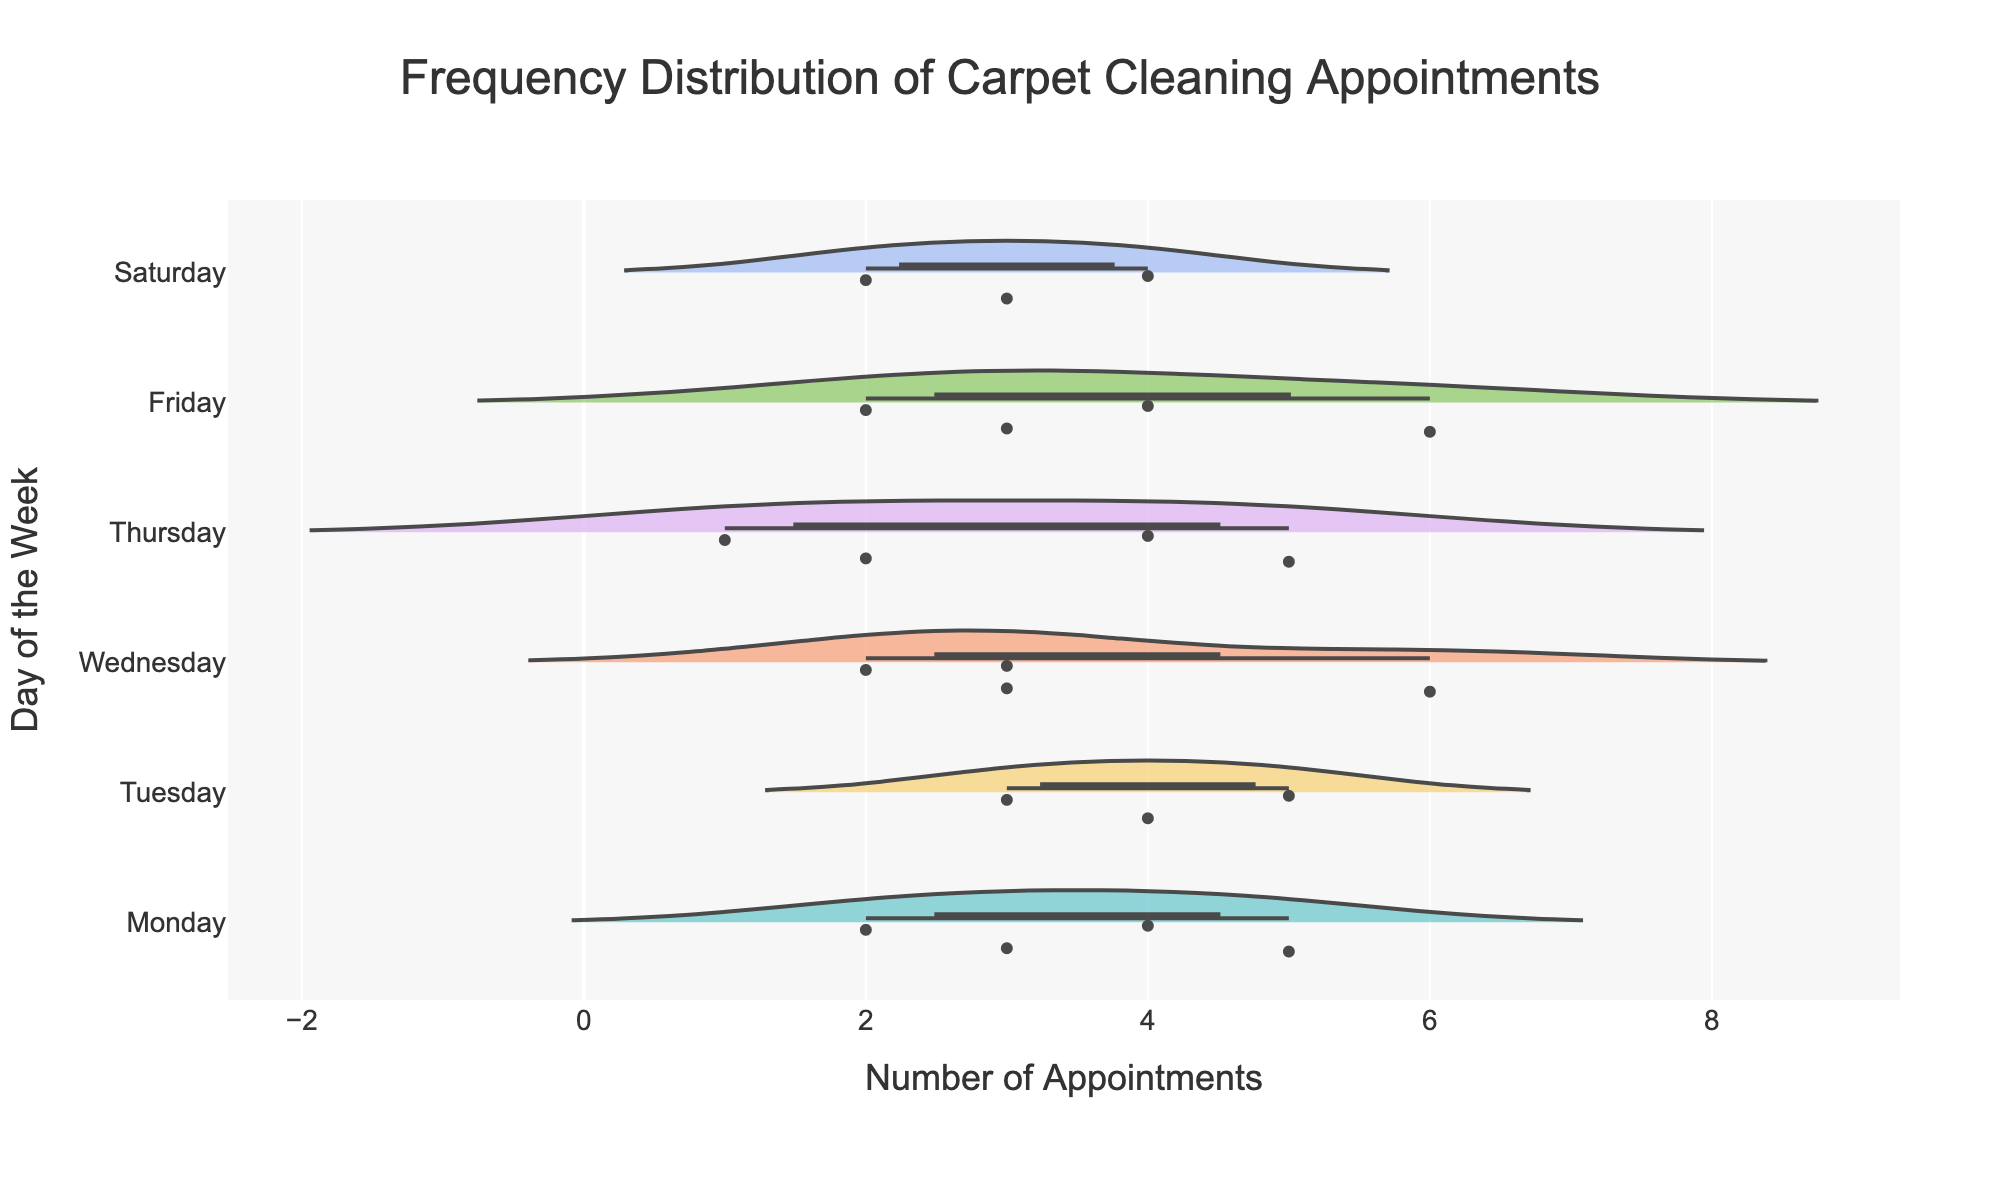What is the title of the figure? The title of the figure is usually displayed at the top and is meant to describe the content of the chart.
Answer: Frequency Distribution of Carpet Cleaning Appointments Which day has the highest number of average appointments? By looking at the width of the violins, Friday shows the widest distribution towards the higher number of appointments, indicating a higher average.
Answer: Friday How many data points are displayed for Wednesday? Each dot represents a data point, and Wednesday has dots at 8:00 AM, 10:00 AM, 1:00 PM, and 4:00 PM, making a total of 4 data points.
Answer: 4 What day has the most variation in appointments? The distribution width of the violin chart helps identify variability. Wednesday shows the widest spread, indicating the most variation in appointments.
Answer: Wednesday Compare the average number of appointments between Monday and Tuesday. Which day is higher? By looking at the center lines of the violin plots, which show the mean line, Monday's mean appears to be slightly higher than Tuesday's.
Answer: Monday What is the median number of appointments on Thursday? The median can be observed from the center box of the violin for Thursday. It is where the thickest part of the violin is located.
Answer: 3.5 Which time slot on Friday has the highest number of appointments? By observing the scatter points on the violin for Friday, 10:00 AM has the highest points at 6 appointments.
Answer: 10:00 AM Which days have appointments that always fall below 5? By examining the highest scatter points on the violin for each day, Saturday always has appointments below 5.
Answer: Saturday Is there any time slot where no appointments are scheduled? Each day has scatter points across the schedule. There are no visible time slots where no appointments are scheduled.
Answer: No On which day does the 9:00 AM slot have the fewest appointments? Comparing the 9:00 AM slot among Tuesday, Thursday, and Friday, Friday shows the fewest appointments with 4.
Answer: Friday 